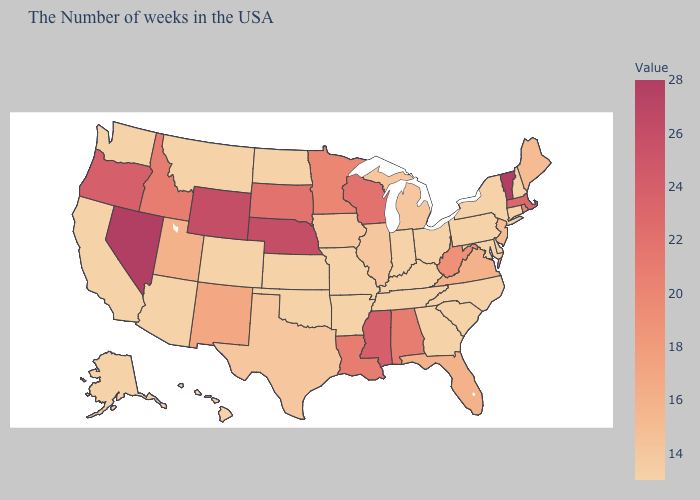Is the legend a continuous bar?
Answer briefly. Yes. Which states have the lowest value in the West?
Write a very short answer. Colorado, Montana, Arizona, California, Washington, Alaska, Hawaii. Does Vermont have the highest value in the USA?
Short answer required. Yes. Among the states that border North Dakota , which have the highest value?
Be succinct. South Dakota. Does Mississippi have the highest value in the South?
Write a very short answer. Yes. Does the map have missing data?
Be succinct. No. 